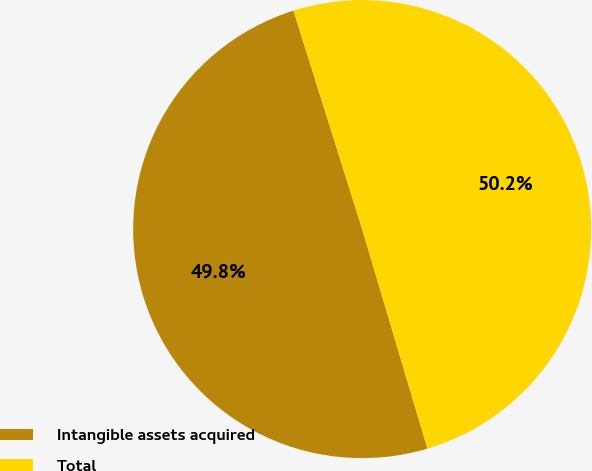Convert chart. <chart><loc_0><loc_0><loc_500><loc_500><pie_chart><fcel>Intangible assets acquired<fcel>Total<nl><fcel>49.75%<fcel>50.25%<nl></chart> 